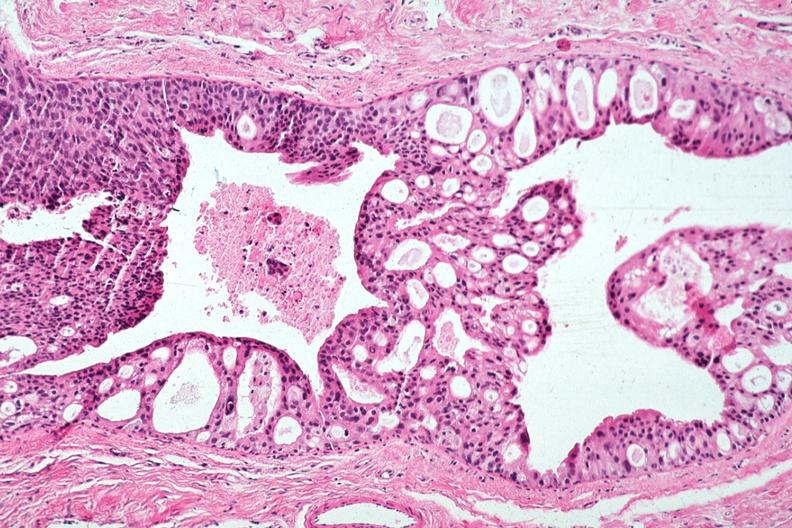s lateral view present?
Answer the question using a single word or phrase. No 